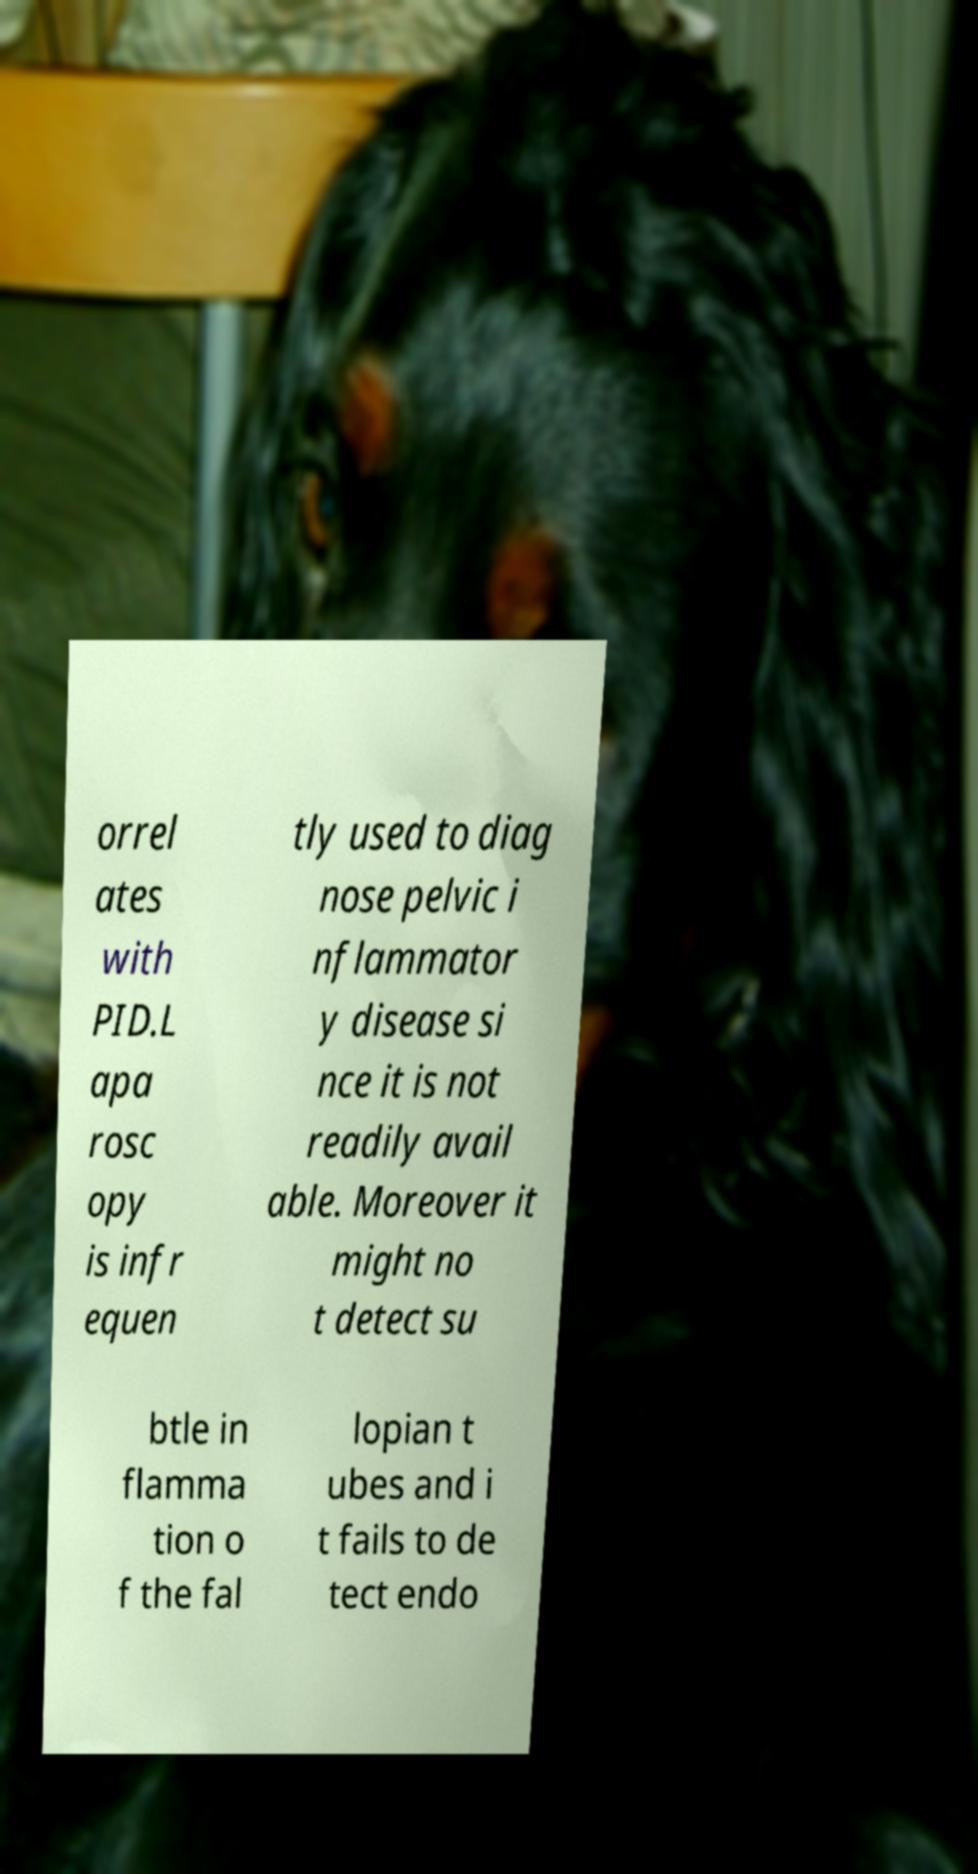Could you extract and type out the text from this image? orrel ates with PID.L apa rosc opy is infr equen tly used to diag nose pelvic i nflammator y disease si nce it is not readily avail able. Moreover it might no t detect su btle in flamma tion o f the fal lopian t ubes and i t fails to de tect endo 